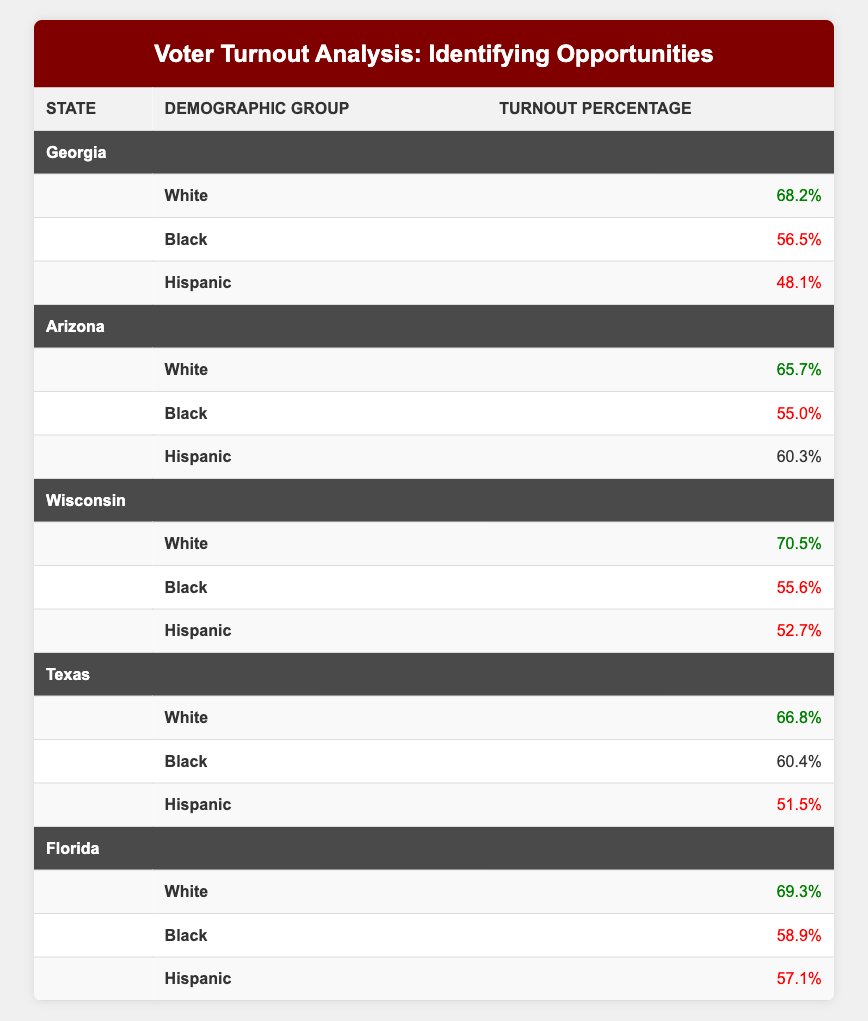What is the voter turnout percentage for Black voters in Georgia? The table lists the voter turnout percentage for Black voters in Georgia as 56.5%. You can find this value by locating the row where the state is Georgia and the demographic group is Black.
Answer: 56.5% Which state has the highest voter turnout percentage for White voters? The highest voter turnout percentage for White voters can be found by comparing all the entries under the demographic group White. The highest value is 70.5%, which is for Wisconsin.
Answer: 70.5% What is the average turnout percentage for Hispanic voters across the five states? The turnout percentages for Hispanic voters are 48.1% (Georgia), 60.3% (Arizona), 52.7% (Wisconsin), 51.5% (Texas), and 57.1% (Florida). We sum these values (48.1 + 60.3 + 52.7 + 51.5 + 57.1) = 270.7 and divide by 5, resulting in an average of 54.14%.
Answer: 54.14% Has the turnout percentage for Hispanic voters in Texas exceeded that of Black voters in the same state? The turnout percentage for Hispanic voters in Texas is 51.5%, and for Black voters it is 60.4%. Since 51.5% is less than 60.4%, the statement is false.
Answer: No Which demographic group had the lowest turnout percentage in Florida? By inspecting the turnout percentages for the Hispanic, Black, and White groups in Florida, we find 57.1% for Hispanic, 58.9% for Black, and 69.3% for White. The lowest turnout among these is 57.1%, belonging to Hispanic voters.
Answer: Hispanic What is the difference in turnout percentage between the highest and lowest demographic groups in Georgia? In Georgia, the highest turnout percentage is 68.2% for White voters and the lowest is 48.1% for Hispanic voters. The difference is calculated as 68.2% - 48.1% = 20.1%.
Answer: 20.1% Is the turnout percentage for Black voters in Arizona higher than that in Texas? The turnout percentage for Black voters in Arizona is 55.0%, while in Texas it is 60.4%. Therefore, since 55.0% is less than 60.4%, the statement is false.
Answer: No What is the total turnout percentage for White voters across all states? The turnout percentages for White voters are 68.2% (Georgia), 65.7% (Arizona), 70.5% (Wisconsin), 66.8% (Texas), and 69.3% (Florida). Sum these values: 68.2 + 65.7 + 70.5 + 66.8 + 69.3 = 340.5.
Answer: 340.5 Which state has the lowest overall turnout percentage for any demographic group? Examination of the table shows that the lowest turnout percentage is 48.1% for Hispanic voters in Georgia, making it the state with the lowest turnout for any demographic.
Answer: Georgia 